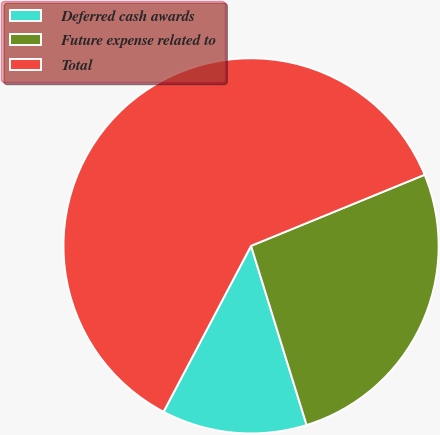Convert chart to OTSL. <chart><loc_0><loc_0><loc_500><loc_500><pie_chart><fcel>Deferred cash awards<fcel>Future expense related to<fcel>Total<nl><fcel>12.51%<fcel>26.4%<fcel>61.09%<nl></chart> 